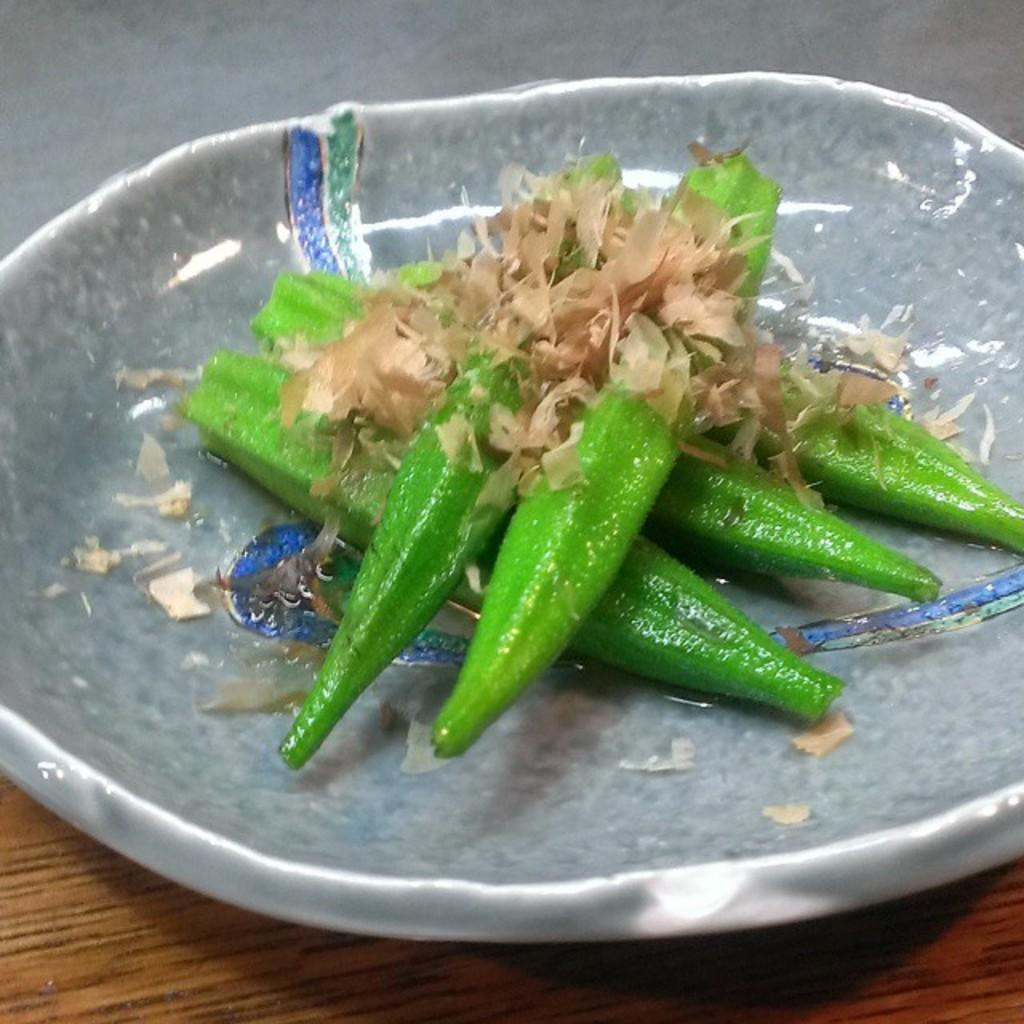What type of eatable items can be seen in the bowl in the image? The specific type of eatable items is not mentioned, but there are eatable things in a bowl in the image. What material is the surface at the bottom of the image? The surface at the bottom of the image is made of wood. What color is visible at the top of the image? The top of the image has an ash color. What company is responsible for manufacturing the cannon visible in the image? There is no cannon present in the image, so it is not possible to determine which company might be responsible for manufacturing it. 